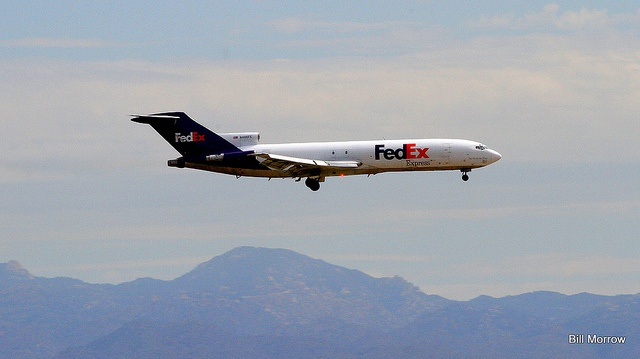Describe the objects in this image and their specific colors. I can see a airplane in lightblue, black, darkgray, lightgray, and gray tones in this image. 